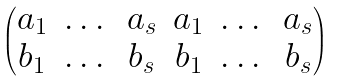Convert formula to latex. <formula><loc_0><loc_0><loc_500><loc_500>\begin{pmatrix} a _ { 1 } & \dots & a _ { s } & a _ { 1 } & \dots & a _ { s } \\ b _ { 1 } & \dots & b _ { s } & b _ { 1 } & \dots & b _ { s } \end{pmatrix}</formula> 